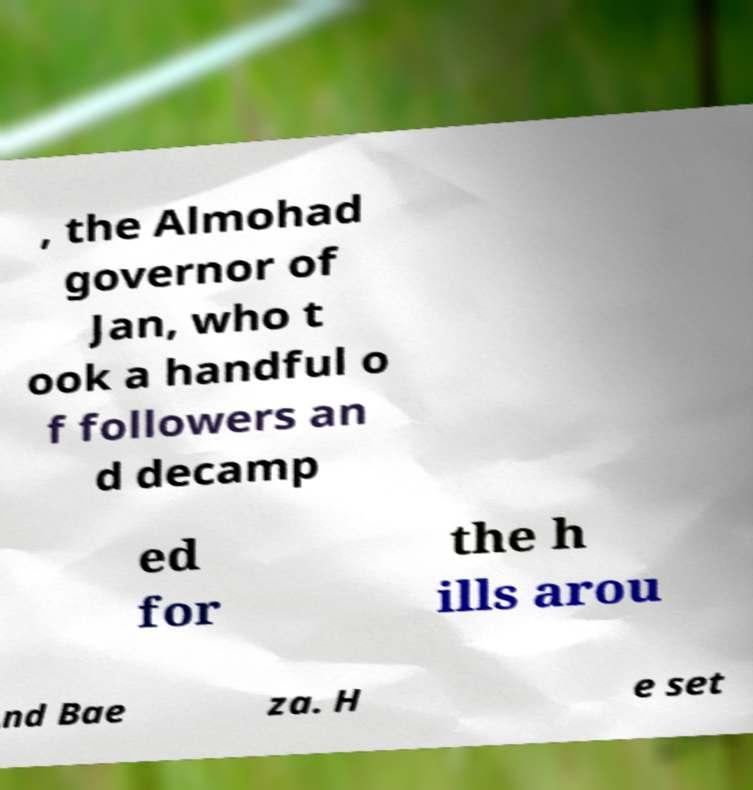For documentation purposes, I need the text within this image transcribed. Could you provide that? , the Almohad governor of Jan, who t ook a handful o f followers an d decamp ed for the h ills arou nd Bae za. H e set 